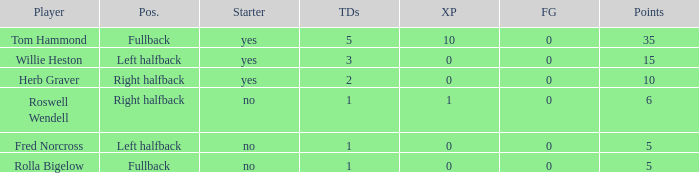What is the lowest number of field goals for a player with 3 touchdowns? 0.0. 